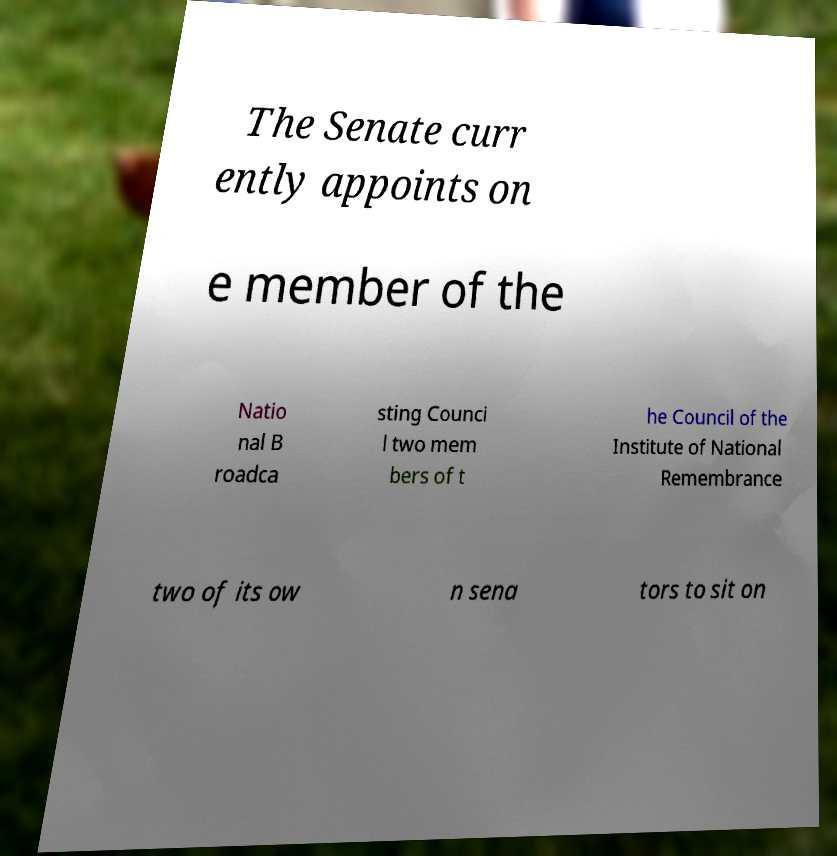Could you extract and type out the text from this image? The Senate curr ently appoints on e member of the Natio nal B roadca sting Counci l two mem bers of t he Council of the Institute of National Remembrance two of its ow n sena tors to sit on 